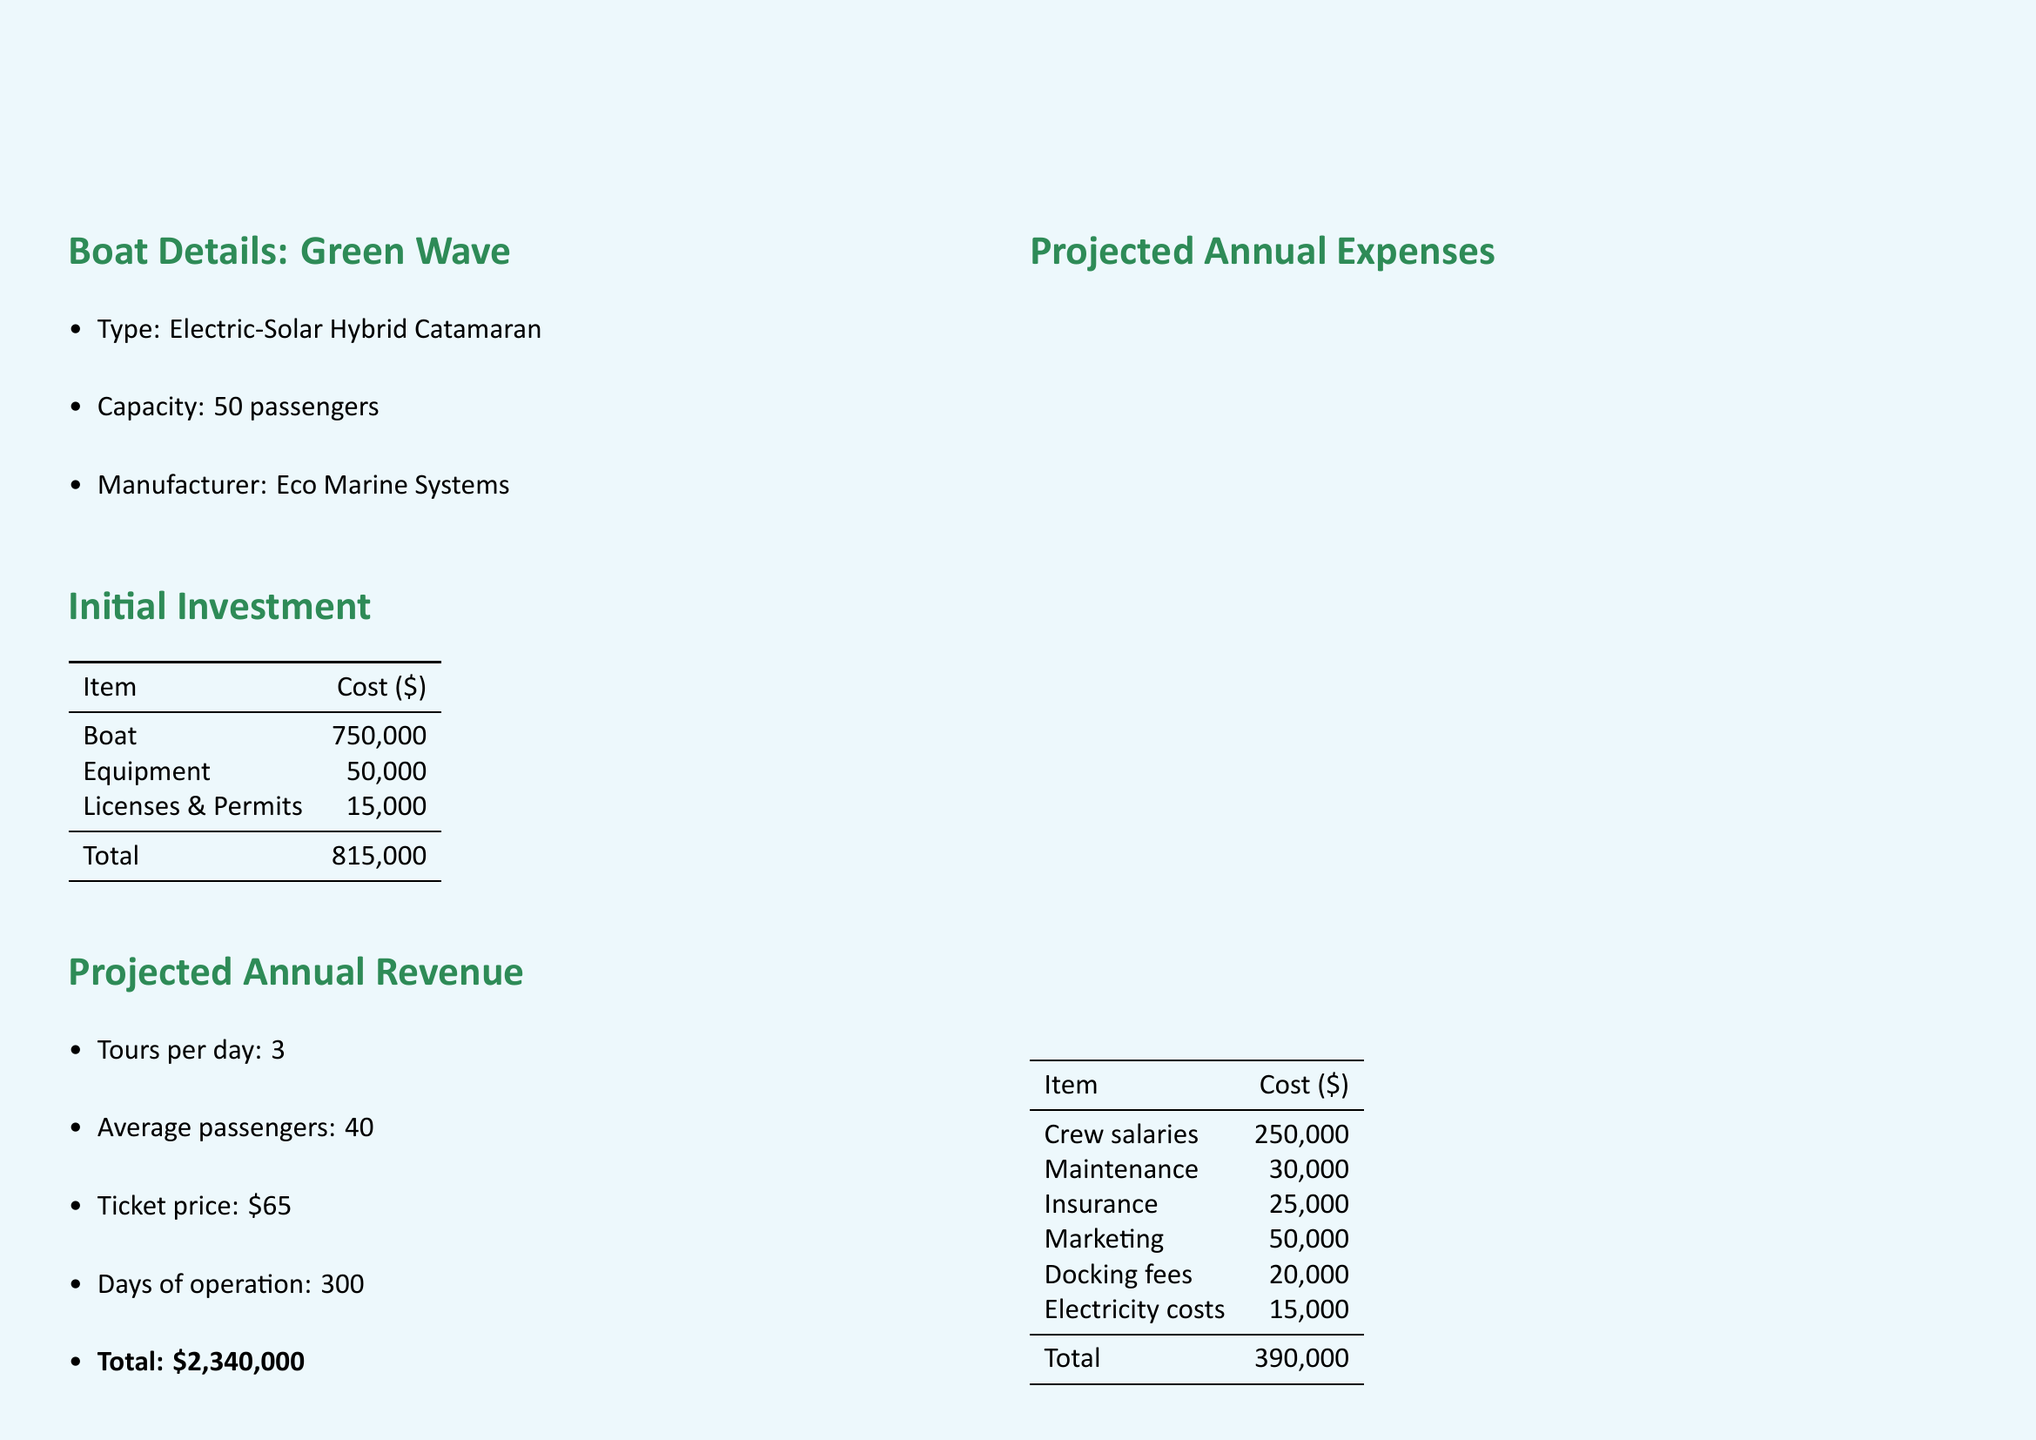What is the name of the new boat? The document specifies that the new boat is named "Green Wave."
Answer: Green Wave What is the total initial investment? The total initial investment sums the costs of the boat, equipment, and licenses, which equals $750,000 + $50,000 + $15,000.
Answer: $815,000 How many tours are projected per day? The document states that there will be 3 tours per day.
Answer: 3 What is the projected annual profit? The annual profit is listed directly in the ROI calculation section as $1,950,000.
Answer: $1,950,000 What percentage is the projected five-year ROI? The document shows the five-year ROI percentage as 1,096%.
Answer: 1,096% How much CO2 emissions reduction is expected? The annual CO2 emissions reduction mentioned is 120 tons.
Answer: 120 tons What is the capacity of the Green Wave? The capacity of the Green Wave, as mentioned in the document, is 50 passengers.
Answer: 50 passengers Which eco-friendly advantage is highlighted in the report? The report highlights "eco-friendly branding aligns with sustainable travel demand."
Answer: Eco-friendly branding What is a potential risk factor mentioned? One of the risk factors mentioned is "weather dependence for solar power generation."
Answer: Weather dependence 